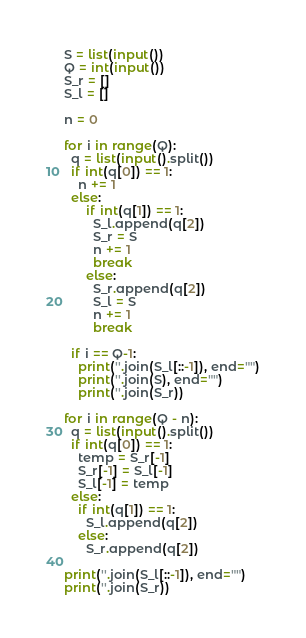Convert code to text. <code><loc_0><loc_0><loc_500><loc_500><_Python_>S = list(input())
Q = int(input())
S_r = []
S_l = []

n = 0

for i in range(Q):
  q = list(input().split())
  if int(q[0]) == 1:
    n += 1
  else:
      if int(q[1]) == 1:
        S_l.append(q[2])
        S_r = S
        n += 1
        break
      else:
        S_r.append(q[2])
        S_l = S
        n += 1
        break

  if i == Q-1:
    print(''.join(S_l[::-1]), end="")
    print(''.join(S), end="")
    print(''.join(S_r))

for i in range(Q - n):
  q = list(input().split())
  if int(q[0]) == 1:
    temp = S_r[-1]
    S_r[-1] = S_l[-1]
    S_l[-1] = temp
  else:
    if int(q[1]) == 1:
      S_l.append(q[2])
    else:
      S_r.append(q[2])

print(''.join(S_l[::-1]), end="")
print(''.join(S_r))</code> 